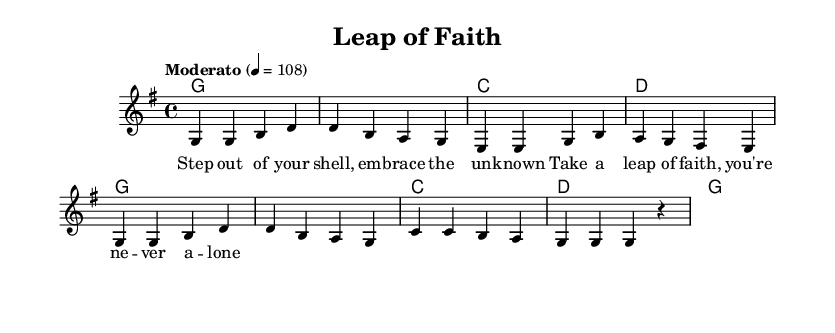What is the key signature of this music? The key signature shown at the beginning of the sheet music indicates G major, which contains one sharp (F sharp).
Answer: G major What is the time signature of this music? The time signature is indicated as 4/4 at the beginning of the sheet music, meaning there are four beats in each measure and a quarter note gets one beat.
Answer: 4/4 What is the tempo marking for this piece? The tempo marking at the top of the sheet music specifies "Moderato" with a metronome marking of 4 = 108, indicating a moderate speed of play.
Answer: Moderato How many measures are in the melody section? Counting the melody section, there are a total of 8 measures shown in the music part.
Answer: 8 measures Which chord follows the G chord in the harmony section? The harmony section shows the progression starting with the G chord and then moving to the C chord based on the chord changes given.
Answer: C What theme do the lyrics in the first verse convey? The lyrics in the first verse express themes of personal growth and stepping out of one’s comfort zone, encouraging bravery and embracing the unknown.
Answer: Personal growth What is the last note of the melody in the score? The last note of the melody, as seen in the music notation, is a quarter note G, which reflects the ending of the phrase for that part of the song.
Answer: G 